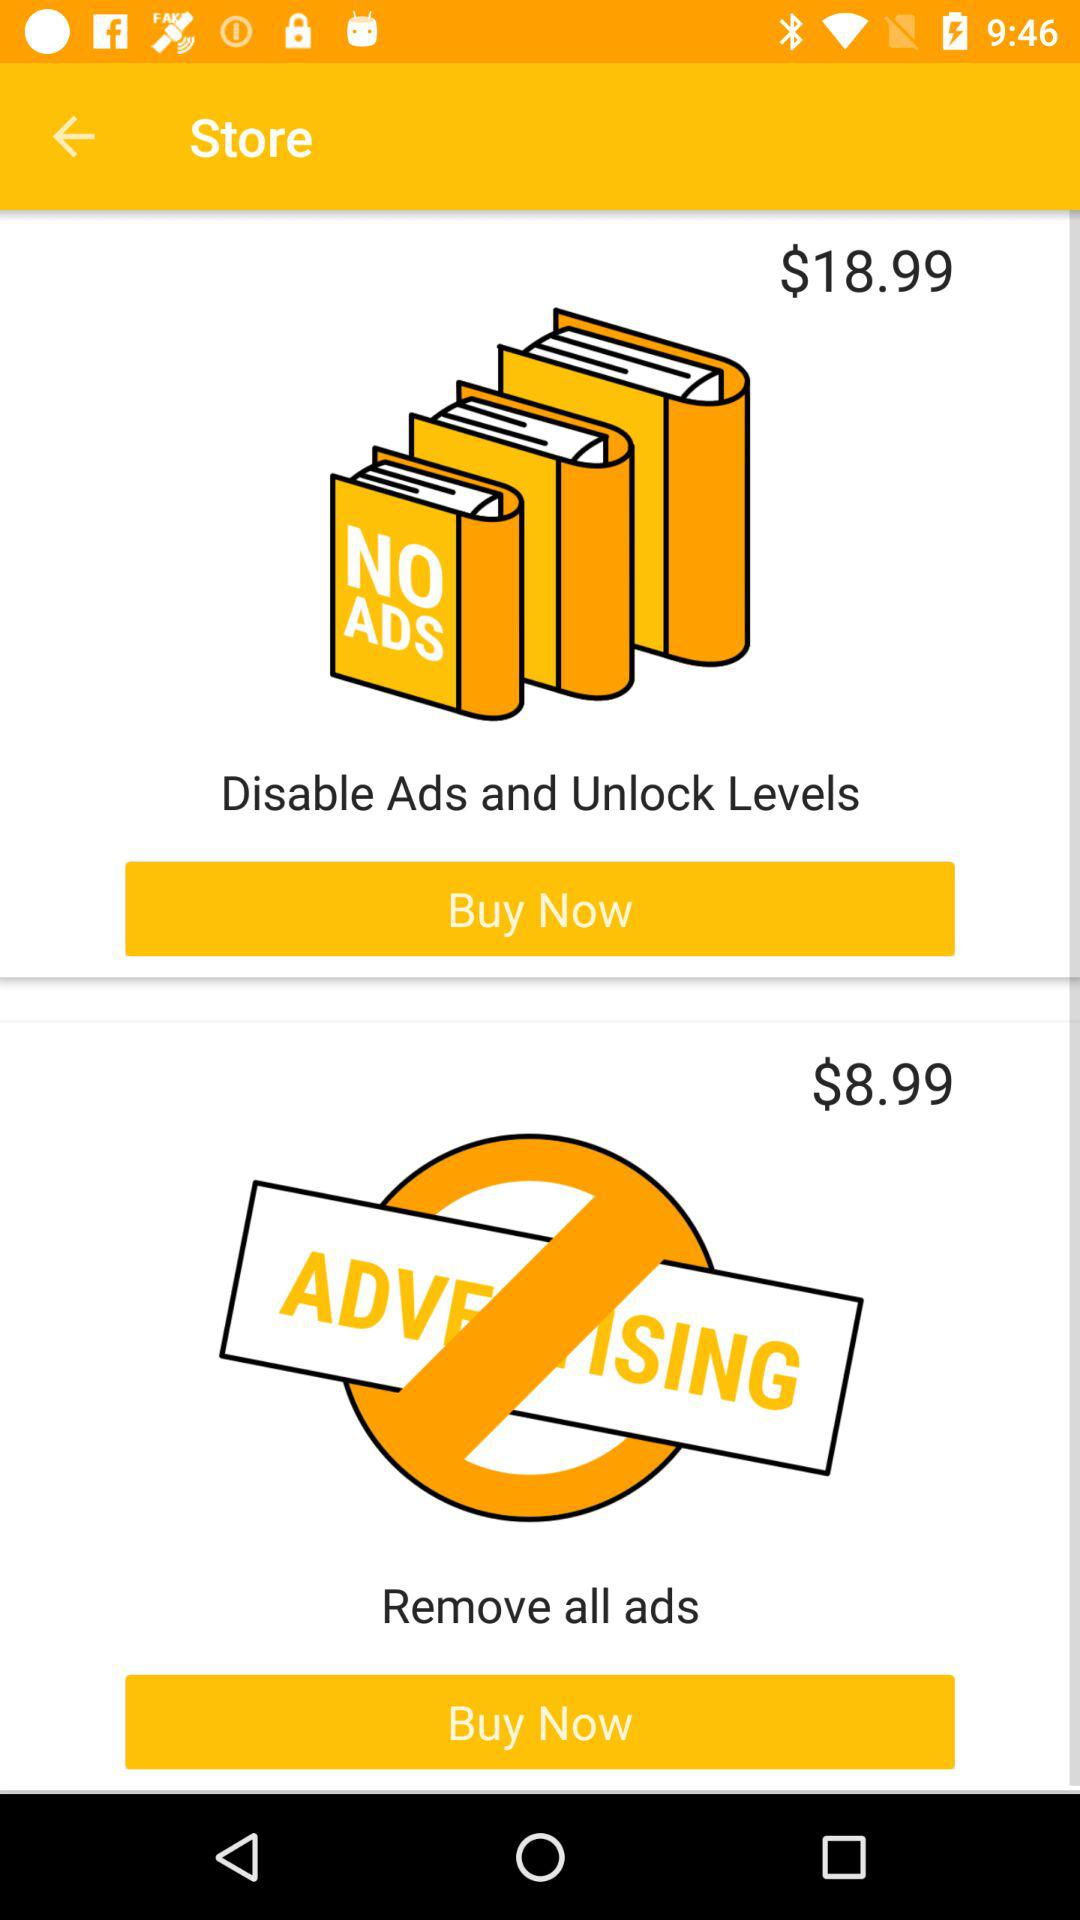Which offer is cheaper, the one that disables ads and unlocks levels or the one that removes all ads?
Answer the question using a single word or phrase. Remove all ads 